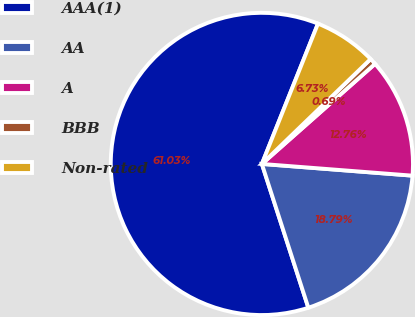Convert chart. <chart><loc_0><loc_0><loc_500><loc_500><pie_chart><fcel>AAA(1)<fcel>AA<fcel>A<fcel>BBB<fcel>Non-rated<nl><fcel>61.03%<fcel>18.79%<fcel>12.76%<fcel>0.69%<fcel>6.73%<nl></chart> 